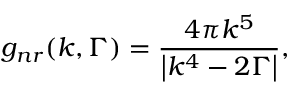Convert formula to latex. <formula><loc_0><loc_0><loc_500><loc_500>{ g _ { n r } } ( k , \Gamma ) = \frac { { 4 \pi { k ^ { 5 } } } } { { \left | { { k ^ { 4 } } - 2 \Gamma } \right | } } ,</formula> 